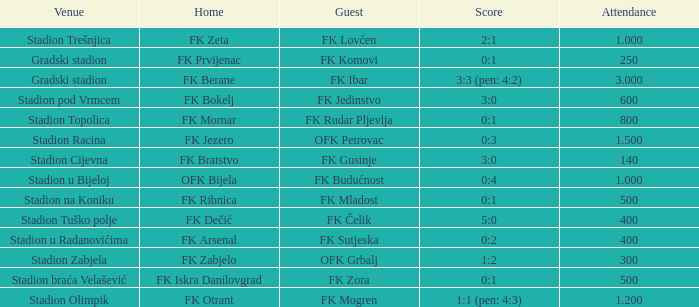What was the attendance of the game that had an away team of FK Mogren? 1.2. 